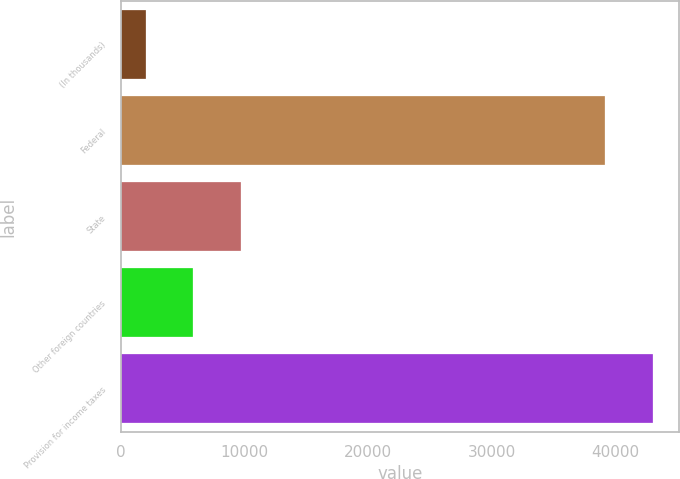<chart> <loc_0><loc_0><loc_500><loc_500><bar_chart><fcel>(In thousands)<fcel>Federal<fcel>State<fcel>Other foreign countries<fcel>Provision for income taxes<nl><fcel>2010<fcel>39139<fcel>9696.4<fcel>5853.2<fcel>42982.2<nl></chart> 